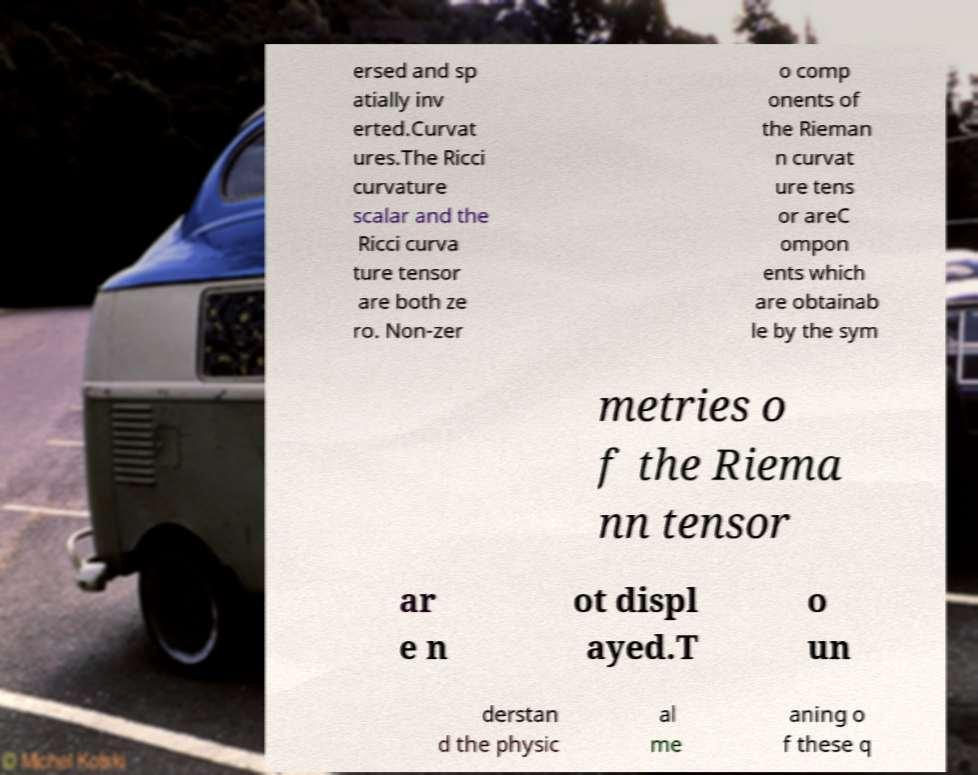Could you extract and type out the text from this image? ersed and sp atially inv erted.Curvat ures.The Ricci curvature scalar and the Ricci curva ture tensor are both ze ro. Non-zer o comp onents of the Rieman n curvat ure tens or areC ompon ents which are obtainab le by the sym metries o f the Riema nn tensor ar e n ot displ ayed.T o un derstan d the physic al me aning o f these q 